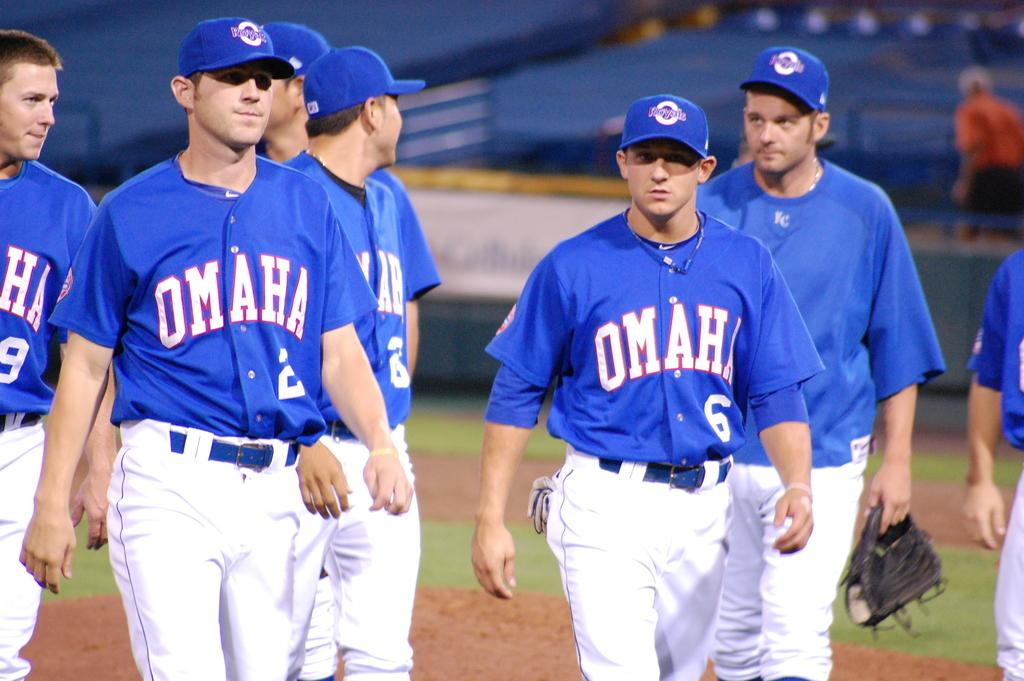<image>
Relay a brief, clear account of the picture shown. Baseball players with blue jerseys that have Omaha in white on them. 